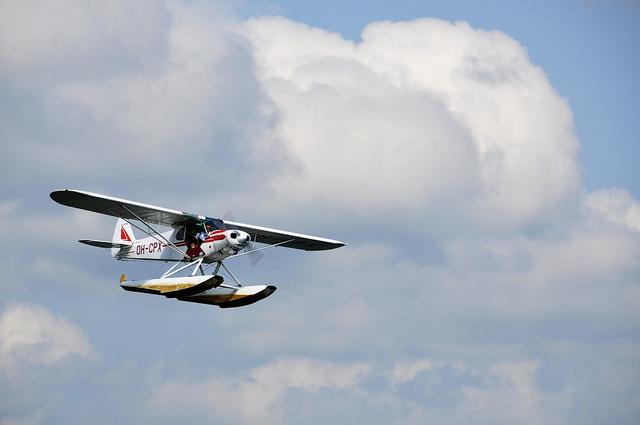Is the airplane in the process of taking off or landing?
Concise answer only. Landing. Why are the wheels visible on the plane?
Give a very brief answer. Pontoon. Is the plane facing toward  the camera or away?
Write a very short answer. Toward. What is about to land on a body of water?
Answer briefly. Plane. Where is it best for this plane to land?
Concise answer only. Water. Is the plane being filmed from the ground?
Concise answer only. Yes. Is the airplane upside down?
Answer briefly. No. What is the color of the sky?
Be succinct. Blue. 